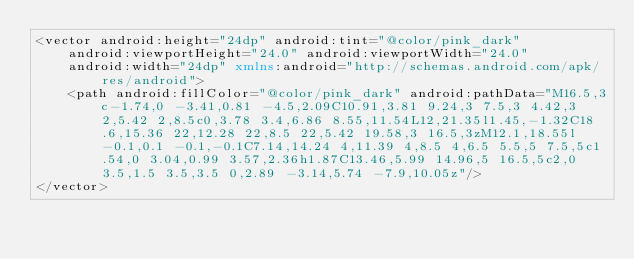Convert code to text. <code><loc_0><loc_0><loc_500><loc_500><_XML_><vector android:height="24dp" android:tint="@color/pink_dark"
    android:viewportHeight="24.0" android:viewportWidth="24.0"
    android:width="24dp" xmlns:android="http://schemas.android.com/apk/res/android">
    <path android:fillColor="@color/pink_dark" android:pathData="M16.5,3c-1.74,0 -3.41,0.81 -4.5,2.09C10.91,3.81 9.24,3 7.5,3 4.42,3 2,5.42 2,8.5c0,3.78 3.4,6.86 8.55,11.54L12,21.35l1.45,-1.32C18.6,15.36 22,12.28 22,8.5 22,5.42 19.58,3 16.5,3zM12.1,18.55l-0.1,0.1 -0.1,-0.1C7.14,14.24 4,11.39 4,8.5 4,6.5 5.5,5 7.5,5c1.54,0 3.04,0.99 3.57,2.36h1.87C13.46,5.99 14.96,5 16.5,5c2,0 3.5,1.5 3.5,3.5 0,2.89 -3.14,5.74 -7.9,10.05z"/>
</vector>
</code> 